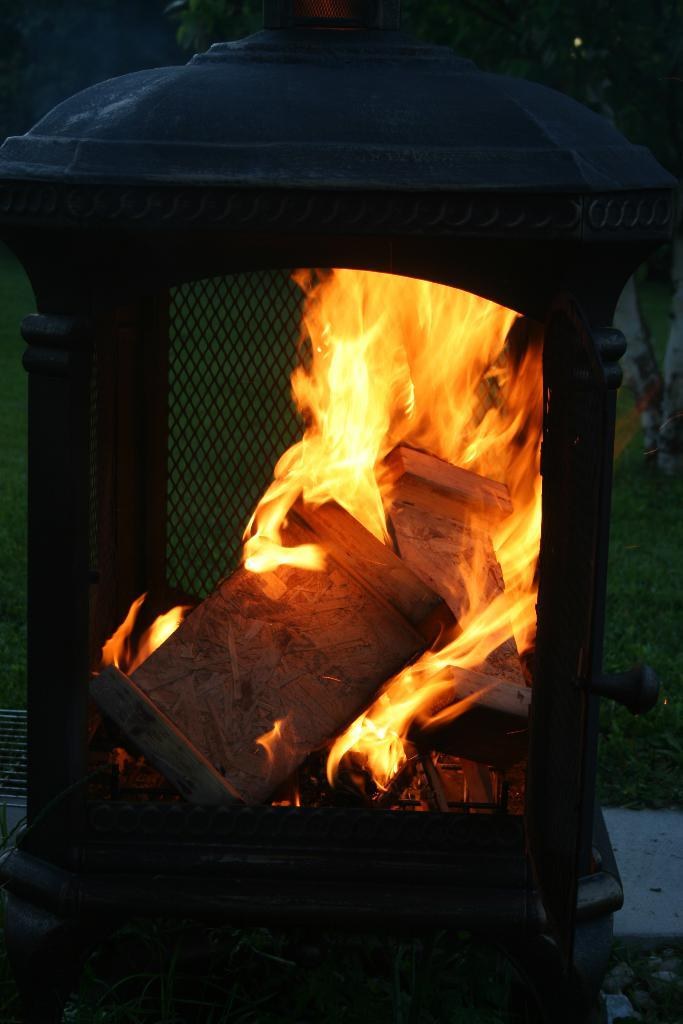What type of structure can be seen in the image? There is a fireplace in the image. What is inside the fireplace? Wooden logs are present in the fireplace. What is happening to the wooden logs in the fireplace? Flames are visible in the fireplace. What can be seen in the background of the image? There are trees and grass in the background of the image. What type of farming equipment can be seen in the image? There is no farming equipment present in the image. What role does the father play in the image? There is no father or any indication of familial relationships in the image. 